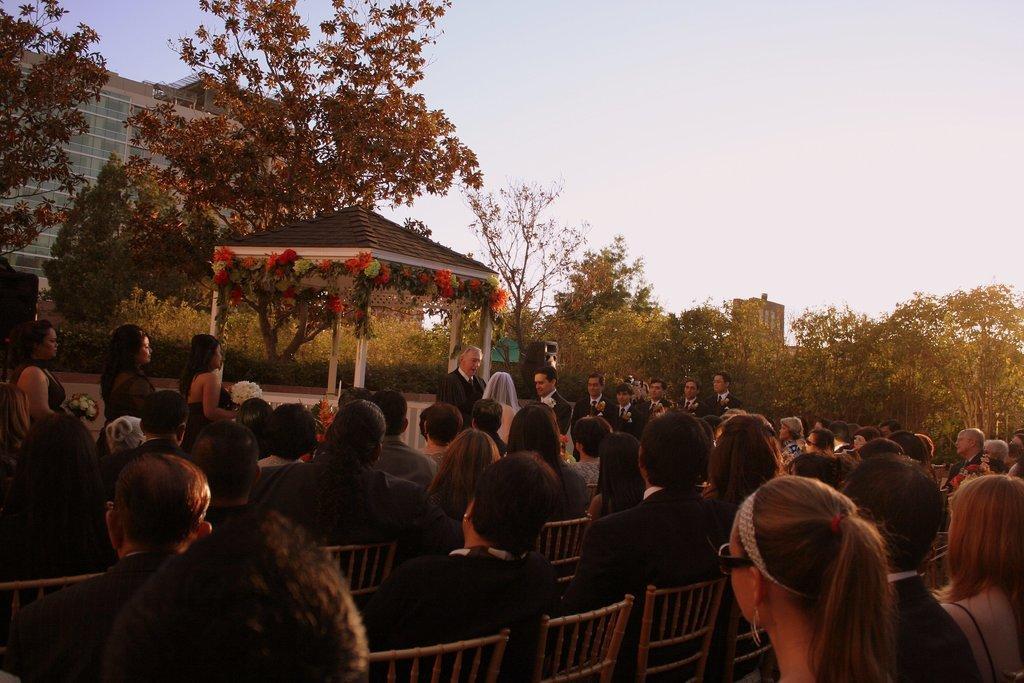Please provide a concise description of this image. At the bottom there are few persons sitting on the chairs and in the background there are few persons standing and among them few persons are holding flower bouquets and there is a gazebo decorated with flowers and we can see trees, buildings, glass doors and sky. 